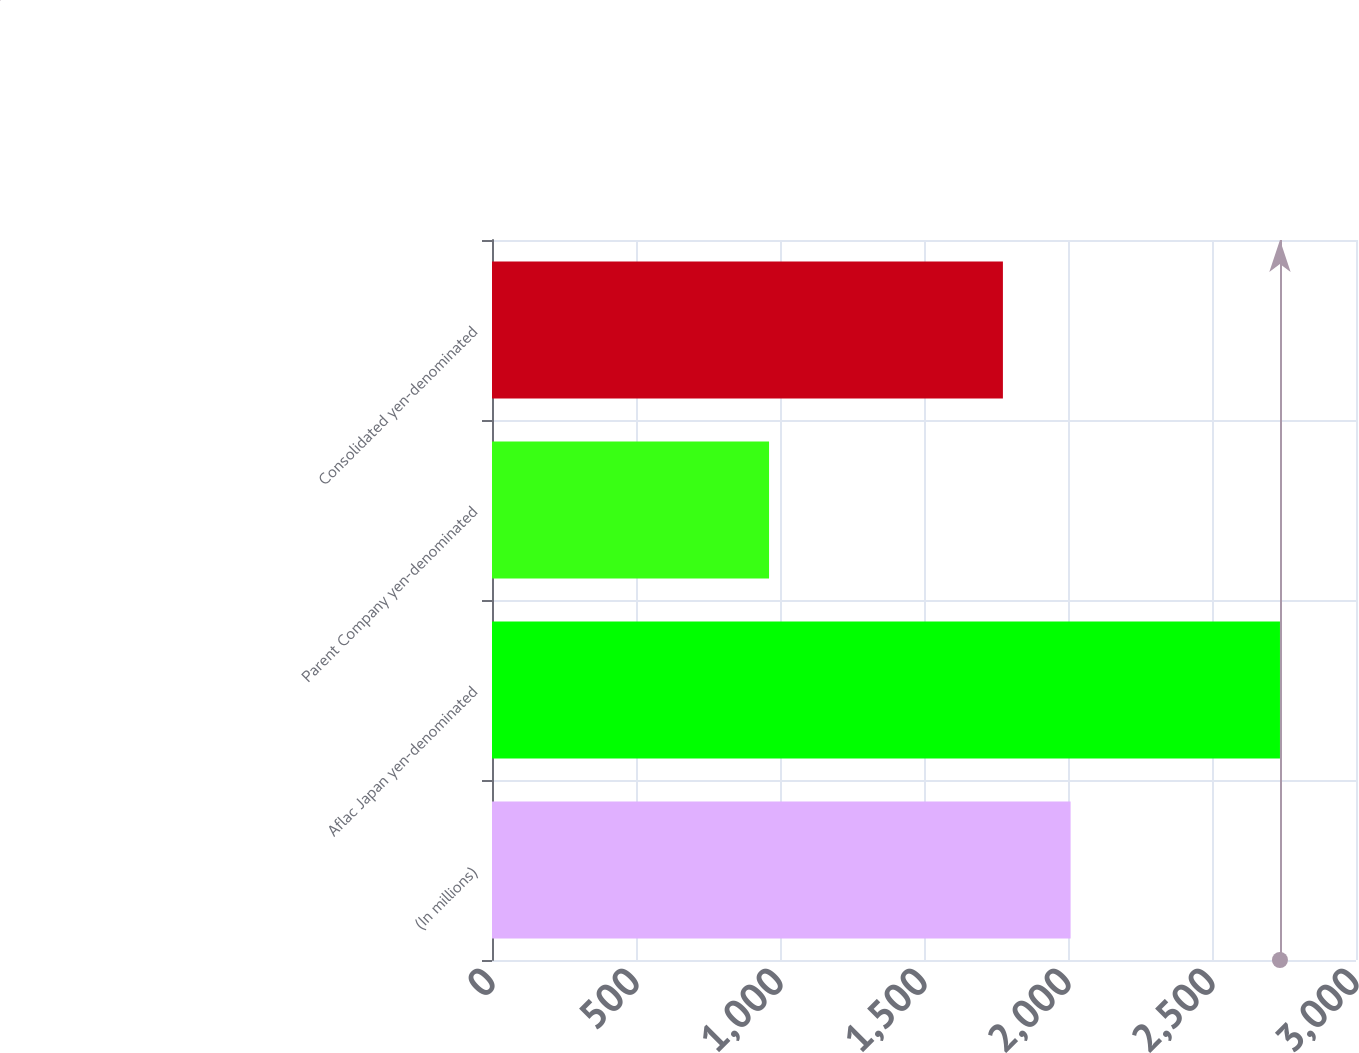Convert chart to OTSL. <chart><loc_0><loc_0><loc_500><loc_500><bar_chart><fcel>(In millions)<fcel>Aflac Japan yen-denominated<fcel>Parent Company yen-denominated<fcel>Consolidated yen-denominated<nl><fcel>2009<fcel>2736<fcel>962<fcel>1774<nl></chart> 